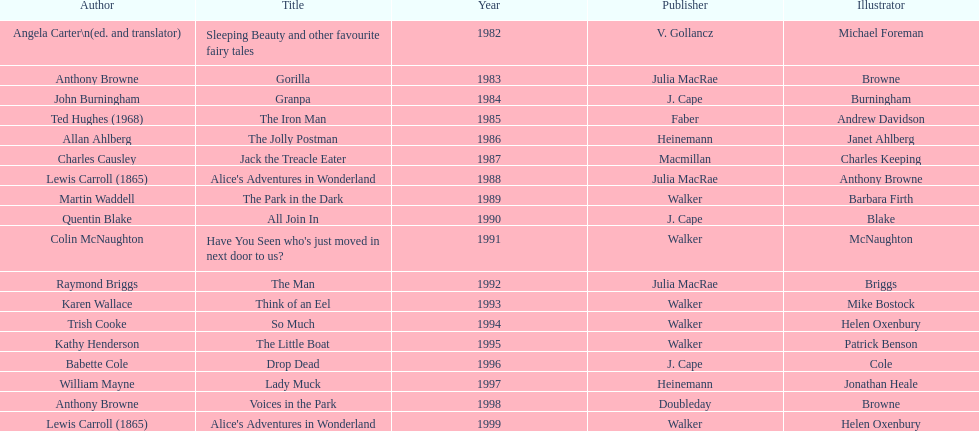How many titles had the same author listed as the illustrator? 7. I'm looking to parse the entire table for insights. Could you assist me with that? {'header': ['Author', 'Title', 'Year', 'Publisher', 'Illustrator'], 'rows': [['Angela Carter\\n(ed. and translator)', 'Sleeping Beauty and other favourite fairy tales', '1982', 'V. Gollancz', 'Michael Foreman'], ['Anthony Browne', 'Gorilla', '1983', 'Julia MacRae', 'Browne'], ['John Burningham', 'Granpa', '1984', 'J. Cape', 'Burningham'], ['Ted Hughes (1968)', 'The Iron Man', '1985', 'Faber', 'Andrew Davidson'], ['Allan Ahlberg', 'The Jolly Postman', '1986', 'Heinemann', 'Janet Ahlberg'], ['Charles Causley', 'Jack the Treacle Eater', '1987', 'Macmillan', 'Charles Keeping'], ['Lewis Carroll (1865)', "Alice's Adventures in Wonderland", '1988', 'Julia MacRae', 'Anthony Browne'], ['Martin Waddell', 'The Park in the Dark', '1989', 'Walker', 'Barbara Firth'], ['Quentin Blake', 'All Join In', '1990', 'J. Cape', 'Blake'], ['Colin McNaughton', "Have You Seen who's just moved in next door to us?", '1991', 'Walker', 'McNaughton'], ['Raymond Briggs', 'The Man', '1992', 'Julia MacRae', 'Briggs'], ['Karen Wallace', 'Think of an Eel', '1993', 'Walker', 'Mike Bostock'], ['Trish Cooke', 'So Much', '1994', 'Walker', 'Helen Oxenbury'], ['Kathy Henderson', 'The Little Boat', '1995', 'Walker', 'Patrick Benson'], ['Babette Cole', 'Drop Dead', '1996', 'J. Cape', 'Cole'], ['William Mayne', 'Lady Muck', '1997', 'Heinemann', 'Jonathan Heale'], ['Anthony Browne', 'Voices in the Park', '1998', 'Doubleday', 'Browne'], ['Lewis Carroll (1865)', "Alice's Adventures in Wonderland", '1999', 'Walker', 'Helen Oxenbury']]} 